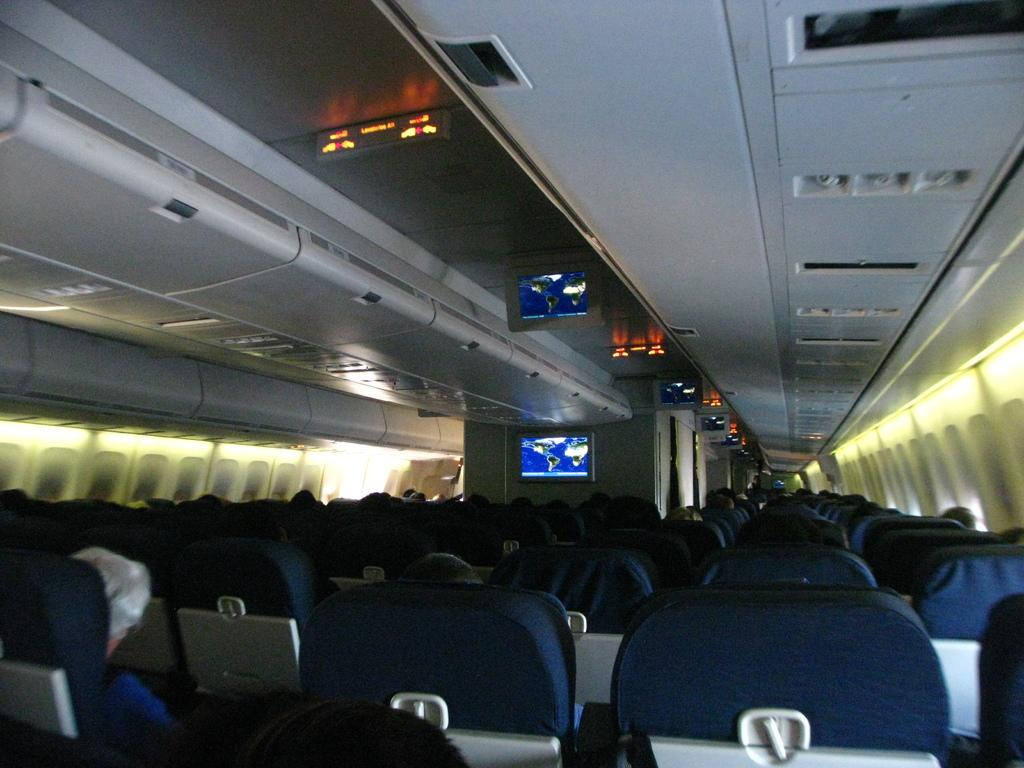What type of furniture is visible in the image? There are many chairs in the image. What are the people on the chairs doing? People are sitting on the chairs. What can be seen mounted on the top in the image? There are screens mounted on the top in the image. How many screens can be seen in the image? There is at least one screen present in the image. Where is the rabbit hiding in the image? There is no rabbit present in the image. What type of furniture is used for bathing in the image? There is no tub or any furniture related to bathing present in the image. 